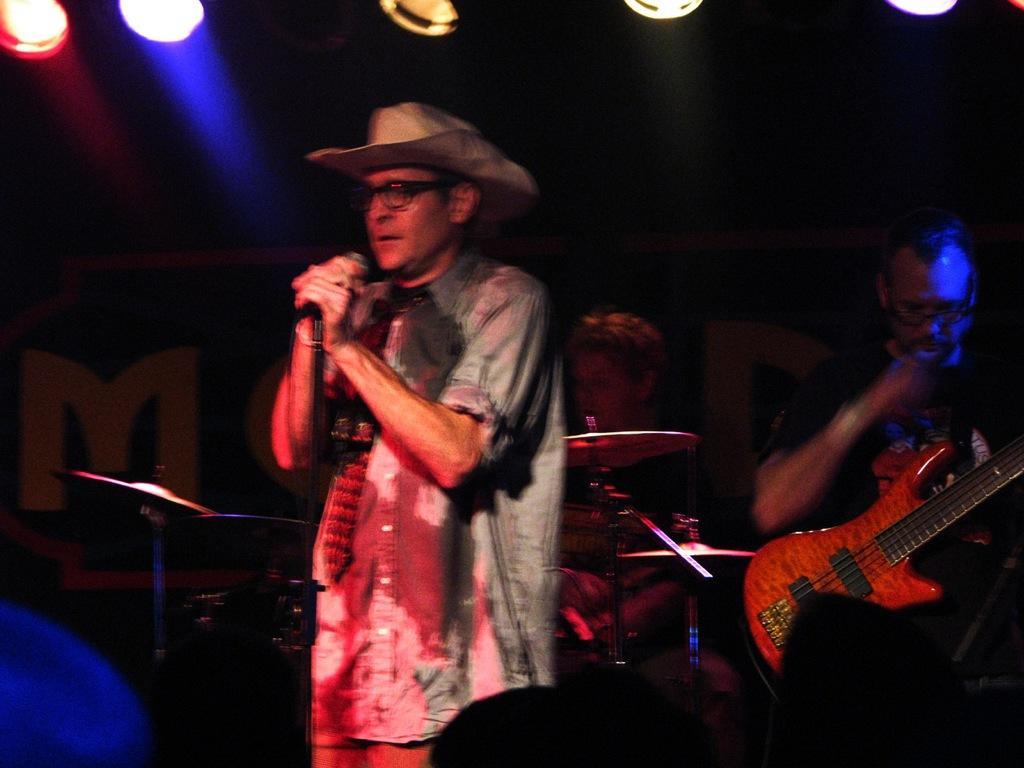How would you summarize this image in a sentence or two? There are few musicians in the picture. In the middle the person is singing. He is holding the microphone. He is wearing a shirt, a hat , glasses. Behind him a person is playing drum. Beside him one person is playing guitar. There are audience in front of him. In the top we can see lights of different color. There is a banner in the background. It is looking like a concert is going on. 